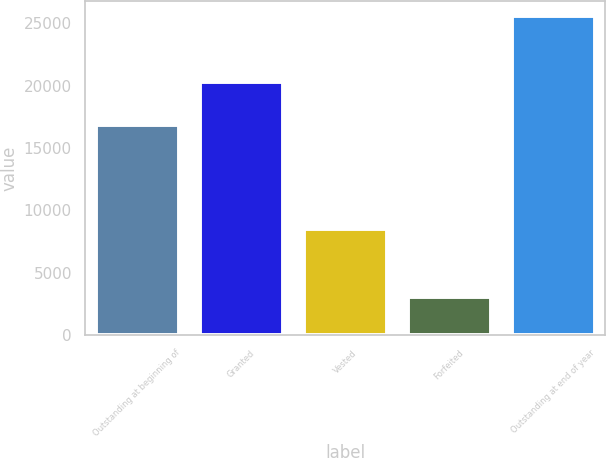Convert chart to OTSL. <chart><loc_0><loc_0><loc_500><loc_500><bar_chart><fcel>Outstanding at beginning of<fcel>Granted<fcel>Vested<fcel>Forfeited<fcel>Outstanding at end of year<nl><fcel>16813<fcel>20316<fcel>8521<fcel>3076<fcel>25532<nl></chart> 